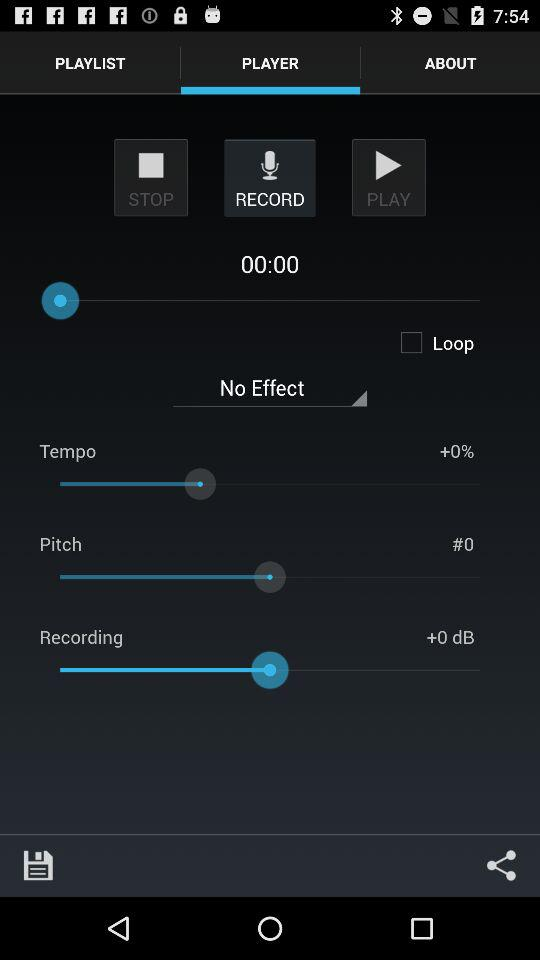What's the duration of the record? The duration is 00:00. 